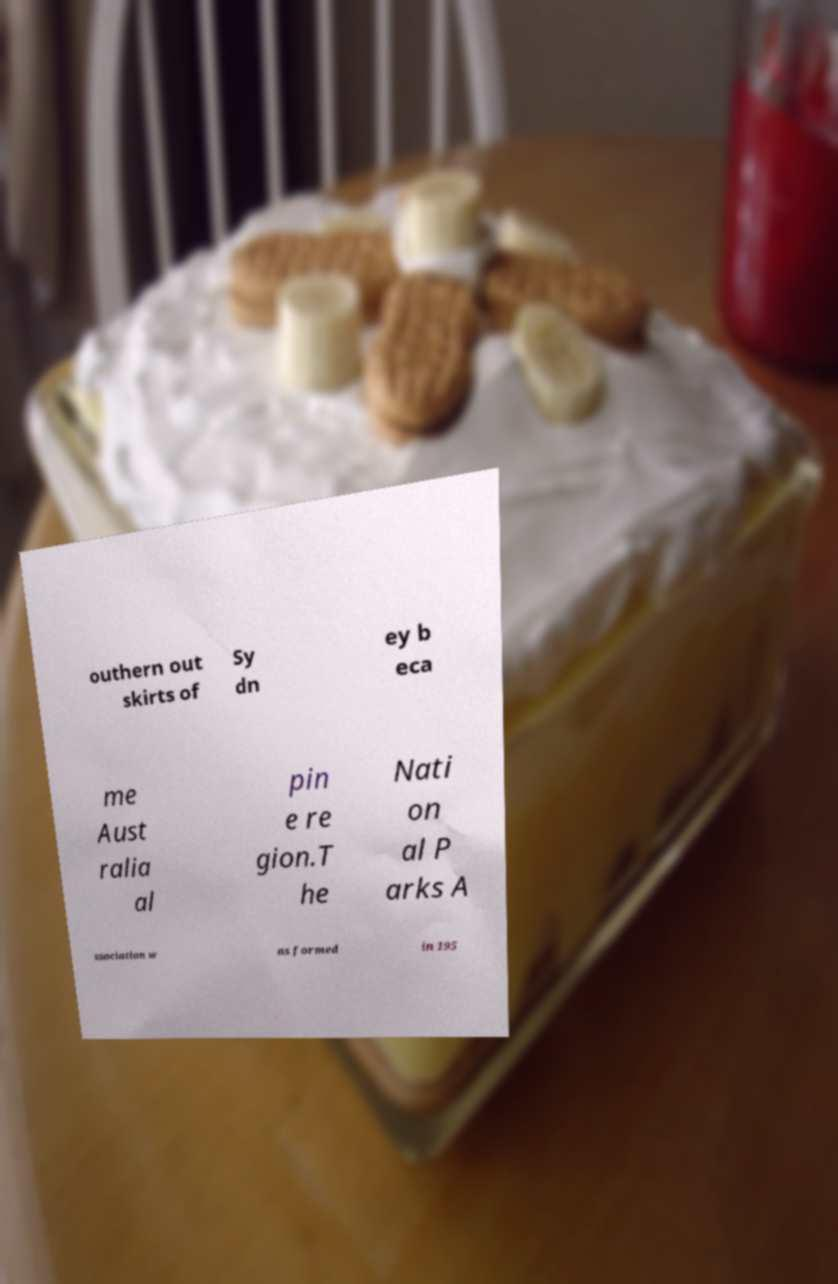I need the written content from this picture converted into text. Can you do that? outhern out skirts of Sy dn ey b eca me Aust ralia al pin e re gion.T he Nati on al P arks A ssociation w as formed in 195 